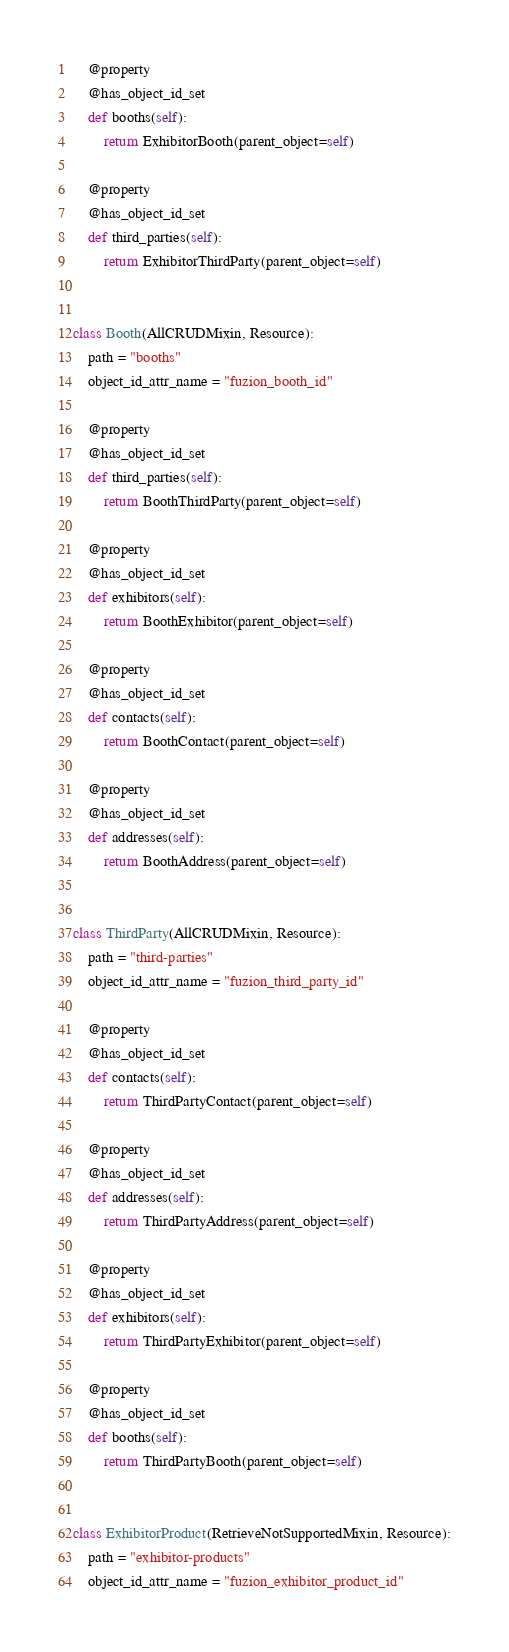Convert code to text. <code><loc_0><loc_0><loc_500><loc_500><_Python_>
    @property
    @has_object_id_set
    def booths(self):
        return ExhibitorBooth(parent_object=self)

    @property
    @has_object_id_set
    def third_parties(self):
        return ExhibitorThirdParty(parent_object=self)


class Booth(AllCRUDMixin, Resource):
    path = "booths"
    object_id_attr_name = "fuzion_booth_id"

    @property
    @has_object_id_set
    def third_parties(self):
        return BoothThirdParty(parent_object=self)

    @property
    @has_object_id_set
    def exhibitors(self):
        return BoothExhibitor(parent_object=self)

    @property
    @has_object_id_set
    def contacts(self):
        return BoothContact(parent_object=self)

    @property
    @has_object_id_set
    def addresses(self):
        return BoothAddress(parent_object=self)


class ThirdParty(AllCRUDMixin, Resource):
    path = "third-parties"
    object_id_attr_name = "fuzion_third_party_id"

    @property
    @has_object_id_set
    def contacts(self):
        return ThirdPartyContact(parent_object=self)

    @property
    @has_object_id_set
    def addresses(self):
        return ThirdPartyAddress(parent_object=self)

    @property
    @has_object_id_set
    def exhibitors(self):
        return ThirdPartyExhibitor(parent_object=self)

    @property
    @has_object_id_set
    def booths(self):
        return ThirdPartyBooth(parent_object=self)


class ExhibitorProduct(RetrieveNotSupportedMixin, Resource):
    path = "exhibitor-products"
    object_id_attr_name = "fuzion_exhibitor_product_id"
</code> 